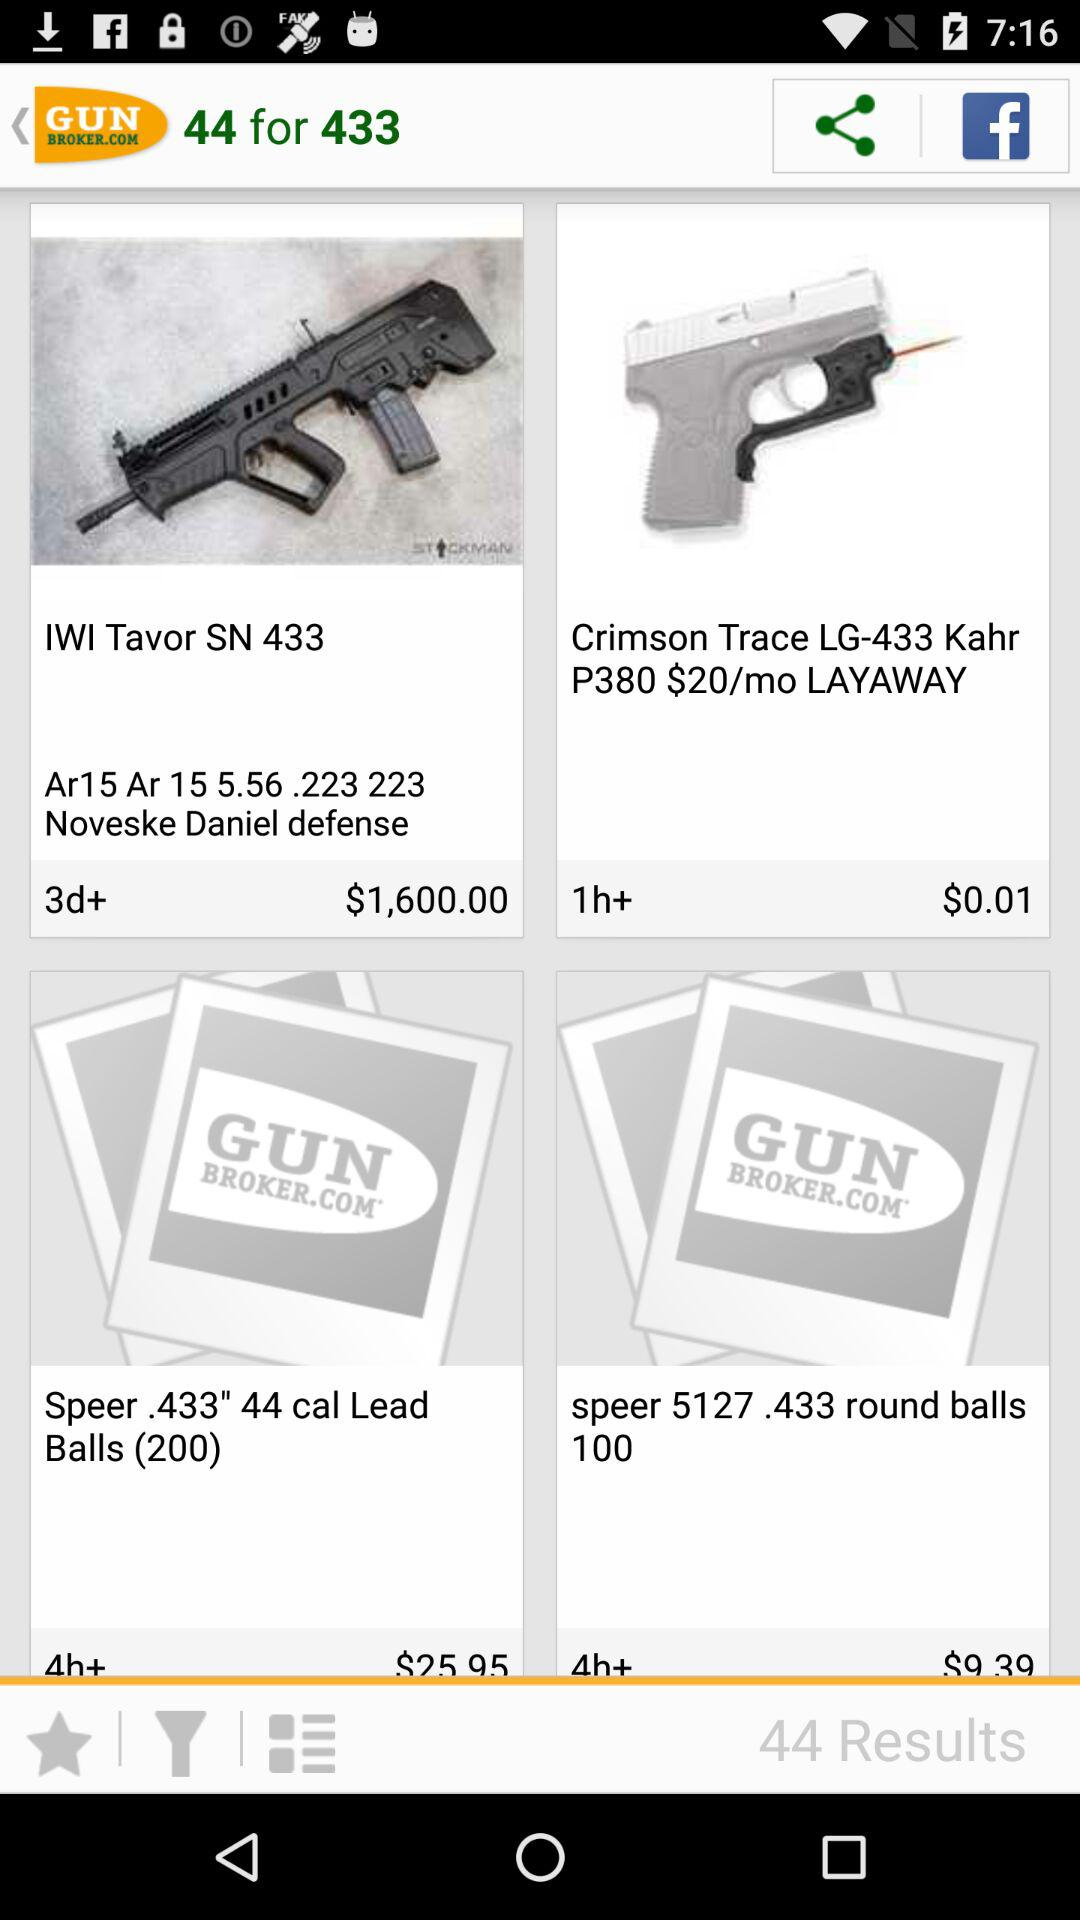How many results are there? There are 44 results. 